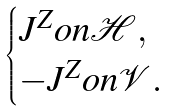<formula> <loc_0><loc_0><loc_500><loc_500>\begin{cases} J ^ { Z } o n \mathcal { H } , \\ - J ^ { Z } o n \mathcal { V } . \end{cases}</formula> 